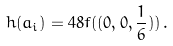<formula> <loc_0><loc_0><loc_500><loc_500>h ( a _ { i } ) = 4 8 f ( ( 0 , 0 , \frac { 1 } { 6 } ) ) \, .</formula> 